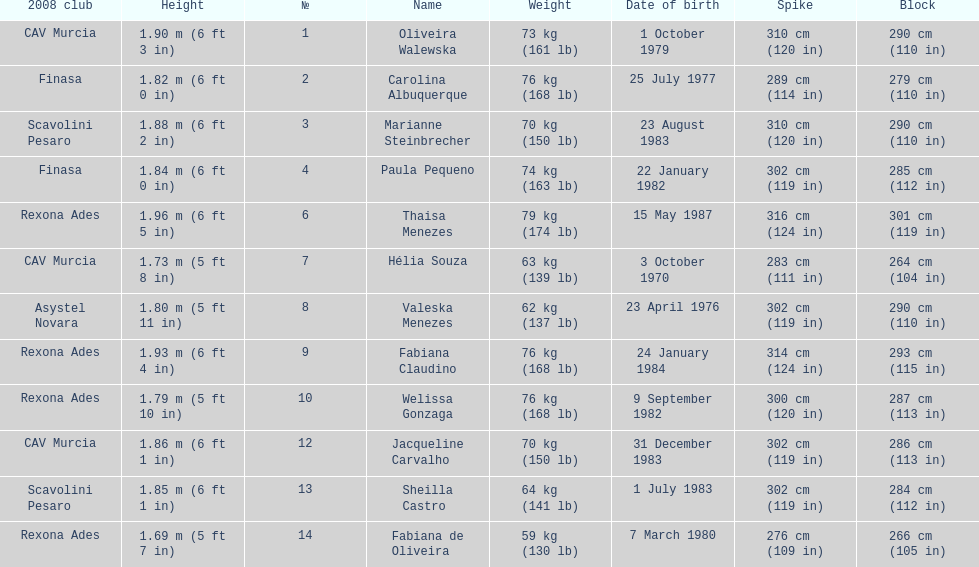Oliveira walewska has the same block as how many other players? 2. 